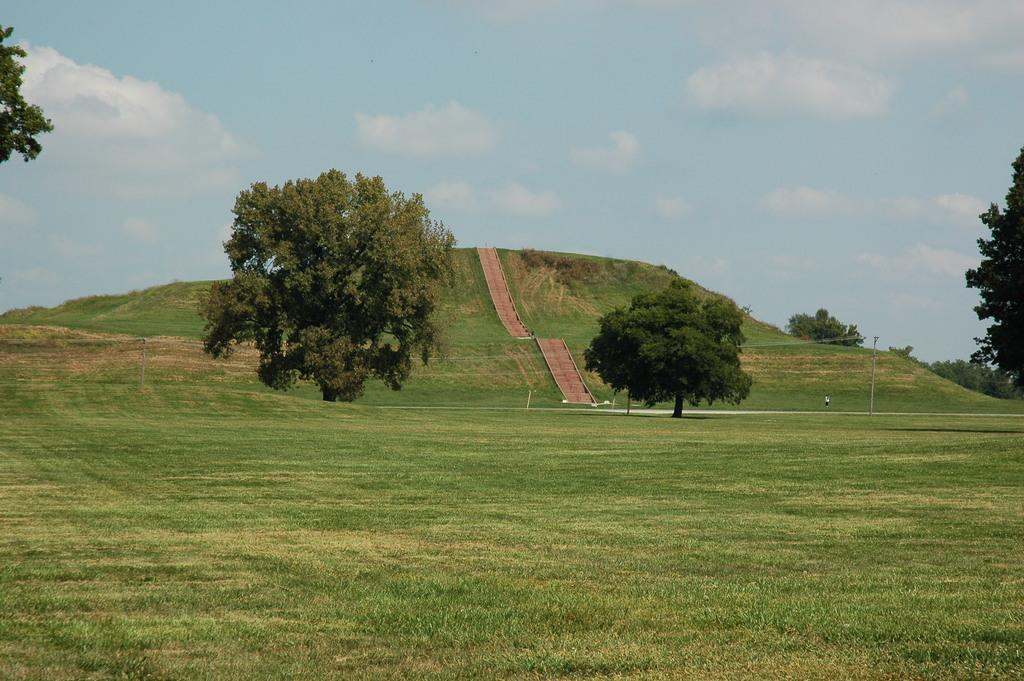What type of vegetation can be seen in the image? There are trees in the image. What type of ground cover is visible in the image? There is grass visible in the image. What part of the natural environment is visible in the image? The sky is visible in the image. What type of knee support is visible in the image? There is no knee support present in the image. What type of garden decoration can be seen in the image? There is no garden decoration present in the image. 